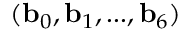Convert formula to latex. <formula><loc_0><loc_0><loc_500><loc_500>( b _ { 0 } , b _ { 1 } , \dots , b _ { 6 } )</formula> 